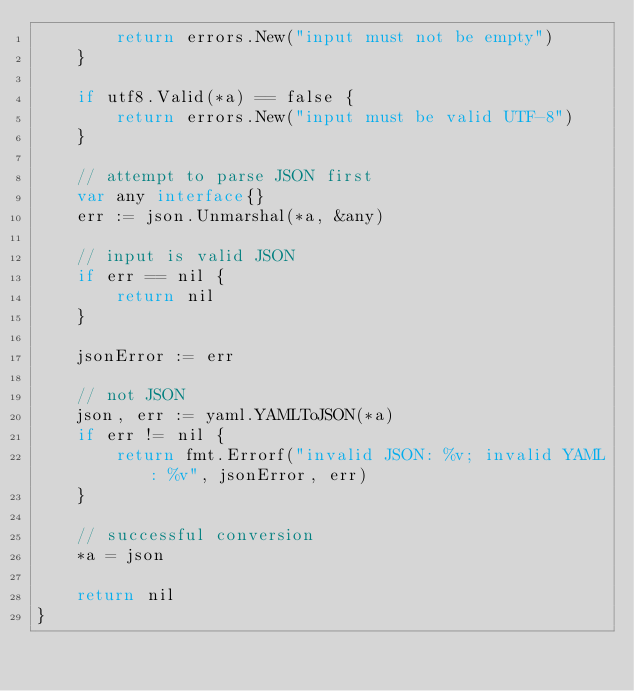<code> <loc_0><loc_0><loc_500><loc_500><_Go_>		return errors.New("input must not be empty")
	}

	if utf8.Valid(*a) == false {
		return errors.New("input must be valid UTF-8")
	}

	// attempt to parse JSON first
	var any interface{}
	err := json.Unmarshal(*a, &any)

	// input is valid JSON
	if err == nil {
		return nil
	}

	jsonError := err

	// not JSON
	json, err := yaml.YAMLToJSON(*a)
	if err != nil {
		return fmt.Errorf("invalid JSON: %v; invalid YAML: %v", jsonError, err)
	}

	// successful conversion
	*a = json

	return nil
}
</code> 